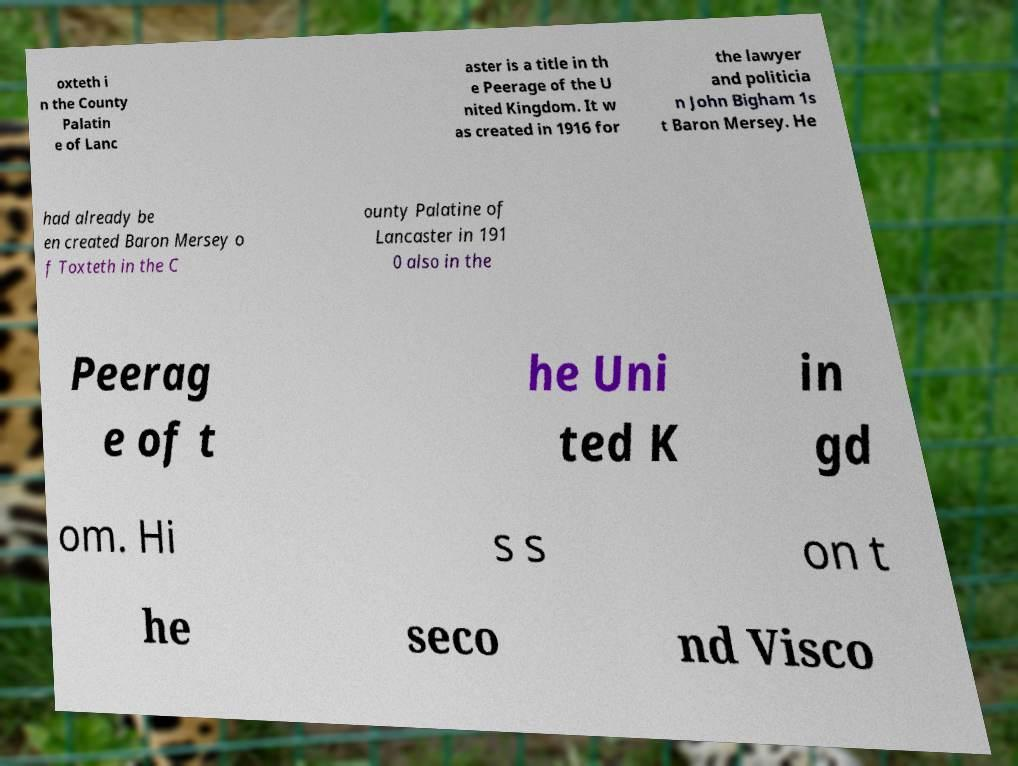Can you accurately transcribe the text from the provided image for me? oxteth i n the County Palatin e of Lanc aster is a title in th e Peerage of the U nited Kingdom. It w as created in 1916 for the lawyer and politicia n John Bigham 1s t Baron Mersey. He had already be en created Baron Mersey o f Toxteth in the C ounty Palatine of Lancaster in 191 0 also in the Peerag e of t he Uni ted K in gd om. Hi s s on t he seco nd Visco 